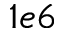<formula> <loc_0><loc_0><loc_500><loc_500>1 e 6</formula> 